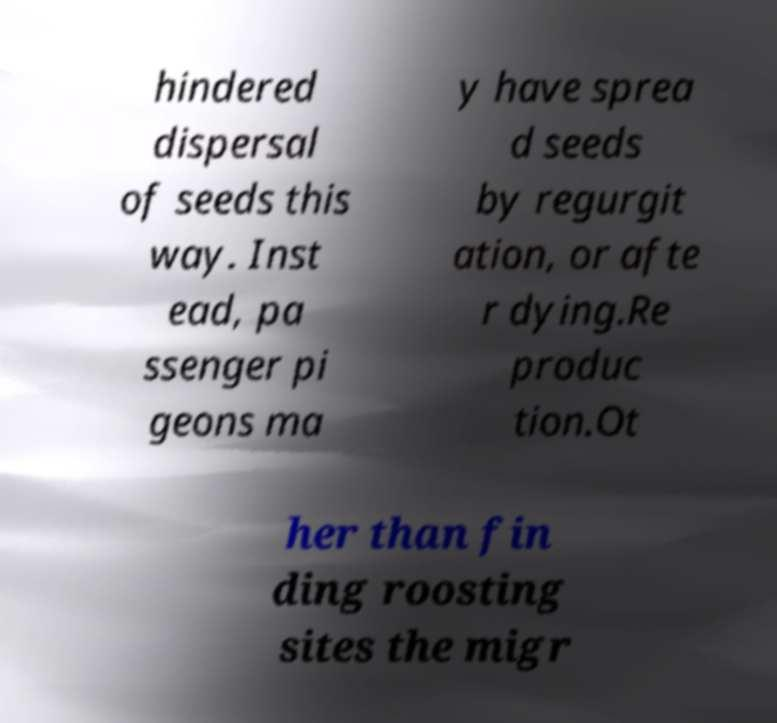Could you extract and type out the text from this image? hindered dispersal of seeds this way. Inst ead, pa ssenger pi geons ma y have sprea d seeds by regurgit ation, or afte r dying.Re produc tion.Ot her than fin ding roosting sites the migr 